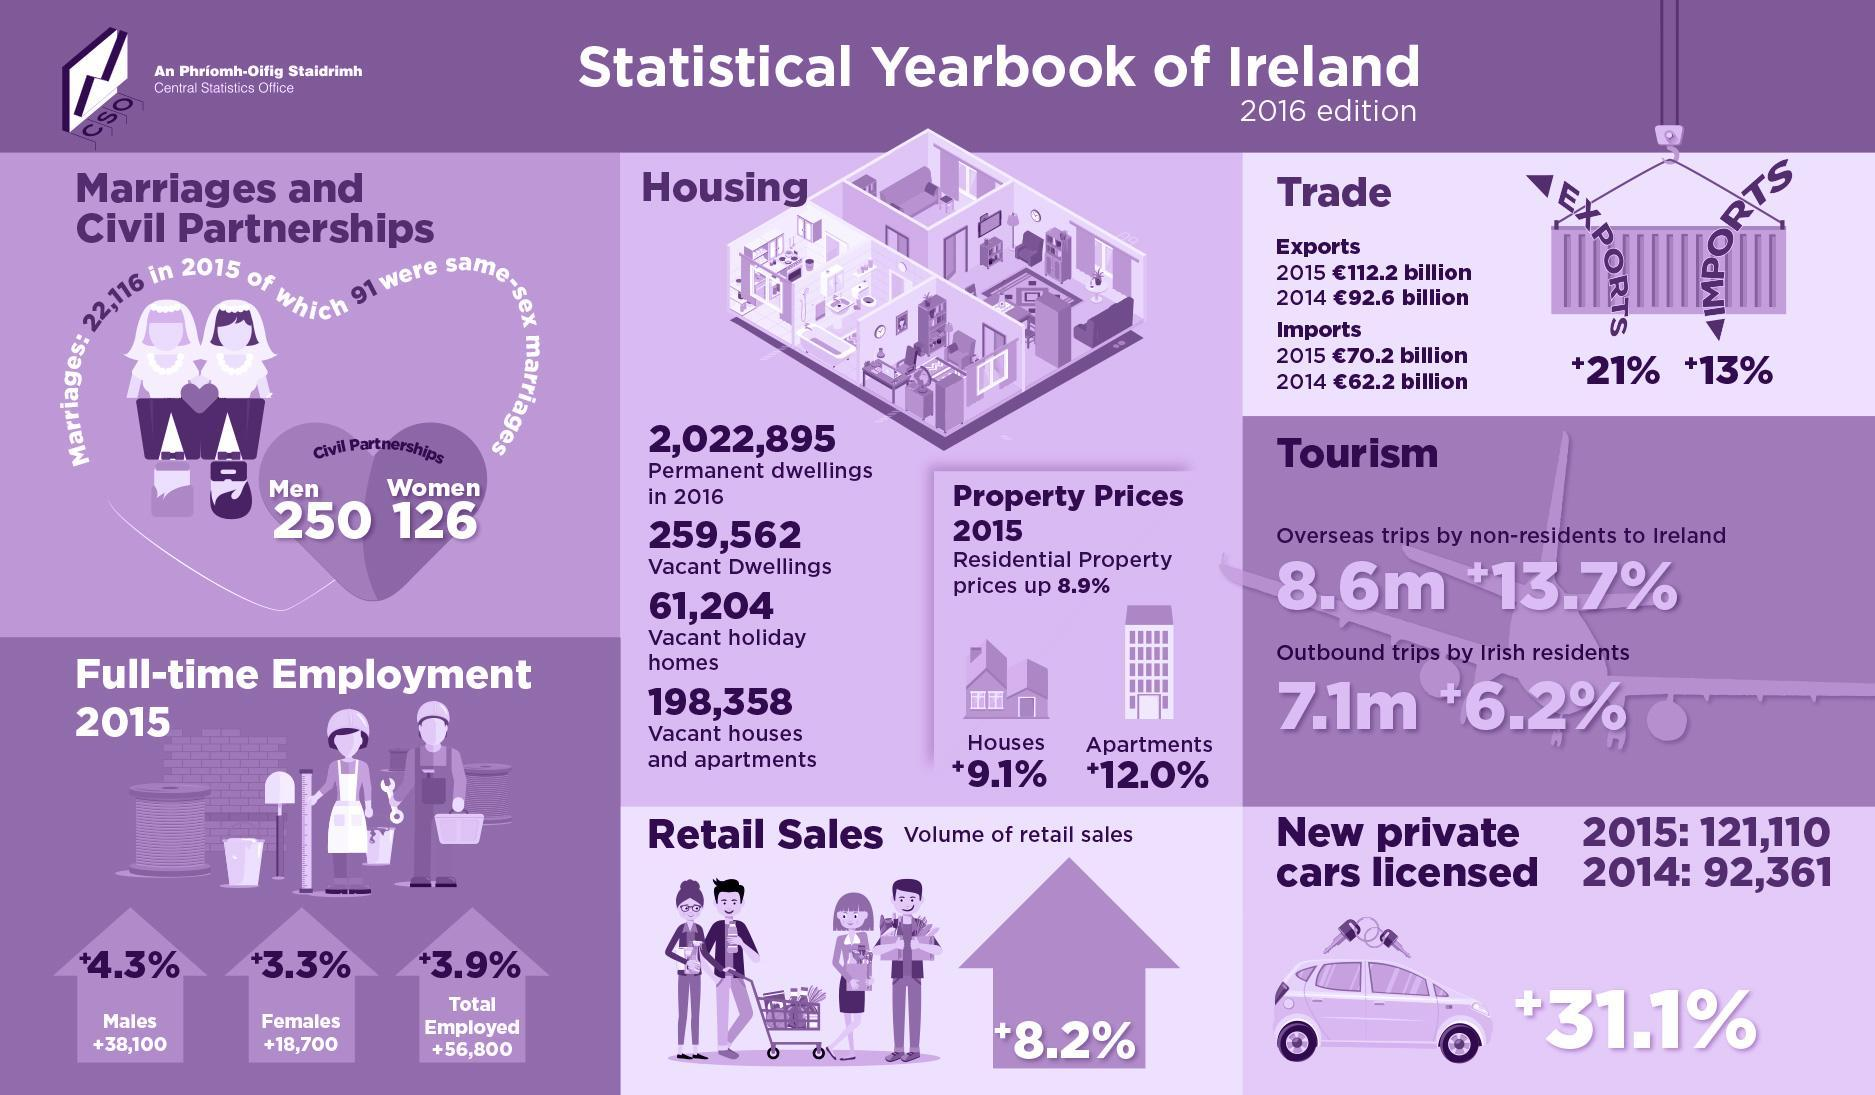What is the percentage hike in property prices of residential apartments in Ireland in 2015?
Answer the question with a short phrase. +12.0% What is the percentage increase of  full-time female employees in Ireland in 2015? 3.3% What is the percentage increase in Ireland exports in 2015? 21% What is the increase in total number of employed people in Ireland in 2015? 56,800 What is the percentage hike in property prices of houses in Ireland in 2015? +9.1% How many women in Ireland are in civil partnership in 2015? 126 How many outbound trips were done by Irish residents in 2016? 7.1m What is the percentage increase in the volume of retail sales in Ireland in 2016? +8.2% What is the percentage increase in Ireland imports in 2015? +13% How many overseas trips were taken by non-residents to Ireland in 2016? 8.6m 